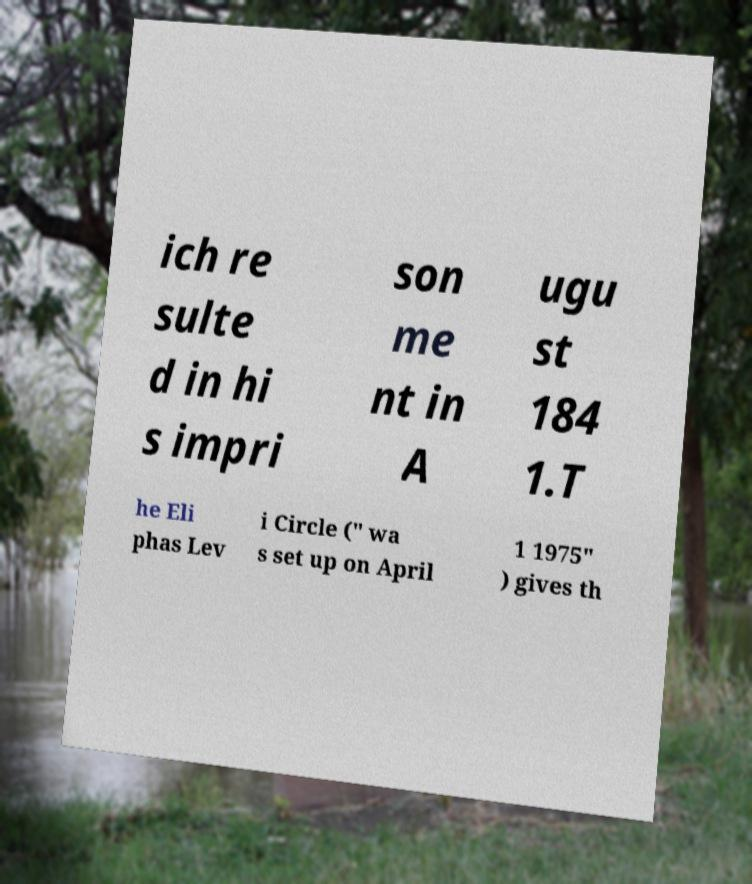Can you read and provide the text displayed in the image?This photo seems to have some interesting text. Can you extract and type it out for me? ich re sulte d in hi s impri son me nt in A ugu st 184 1.T he Eli phas Lev i Circle (" wa s set up on April 1 1975" ) gives th 